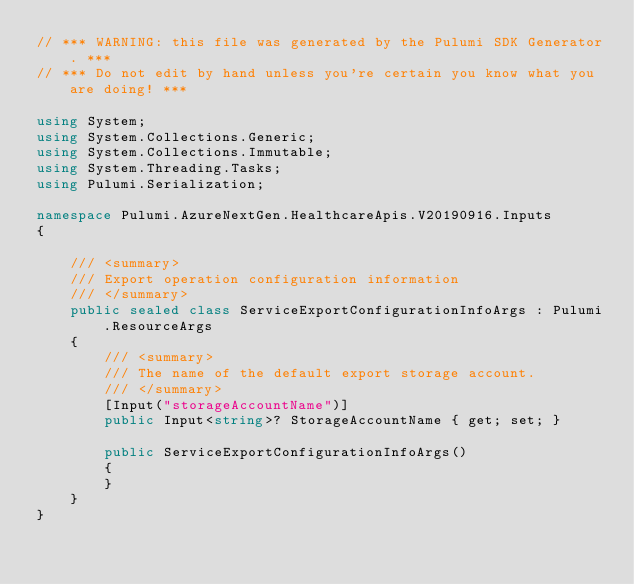Convert code to text. <code><loc_0><loc_0><loc_500><loc_500><_C#_>// *** WARNING: this file was generated by the Pulumi SDK Generator. ***
// *** Do not edit by hand unless you're certain you know what you are doing! ***

using System;
using System.Collections.Generic;
using System.Collections.Immutable;
using System.Threading.Tasks;
using Pulumi.Serialization;

namespace Pulumi.AzureNextGen.HealthcareApis.V20190916.Inputs
{

    /// <summary>
    /// Export operation configuration information
    /// </summary>
    public sealed class ServiceExportConfigurationInfoArgs : Pulumi.ResourceArgs
    {
        /// <summary>
        /// The name of the default export storage account.
        /// </summary>
        [Input("storageAccountName")]
        public Input<string>? StorageAccountName { get; set; }

        public ServiceExportConfigurationInfoArgs()
        {
        }
    }
}
</code> 